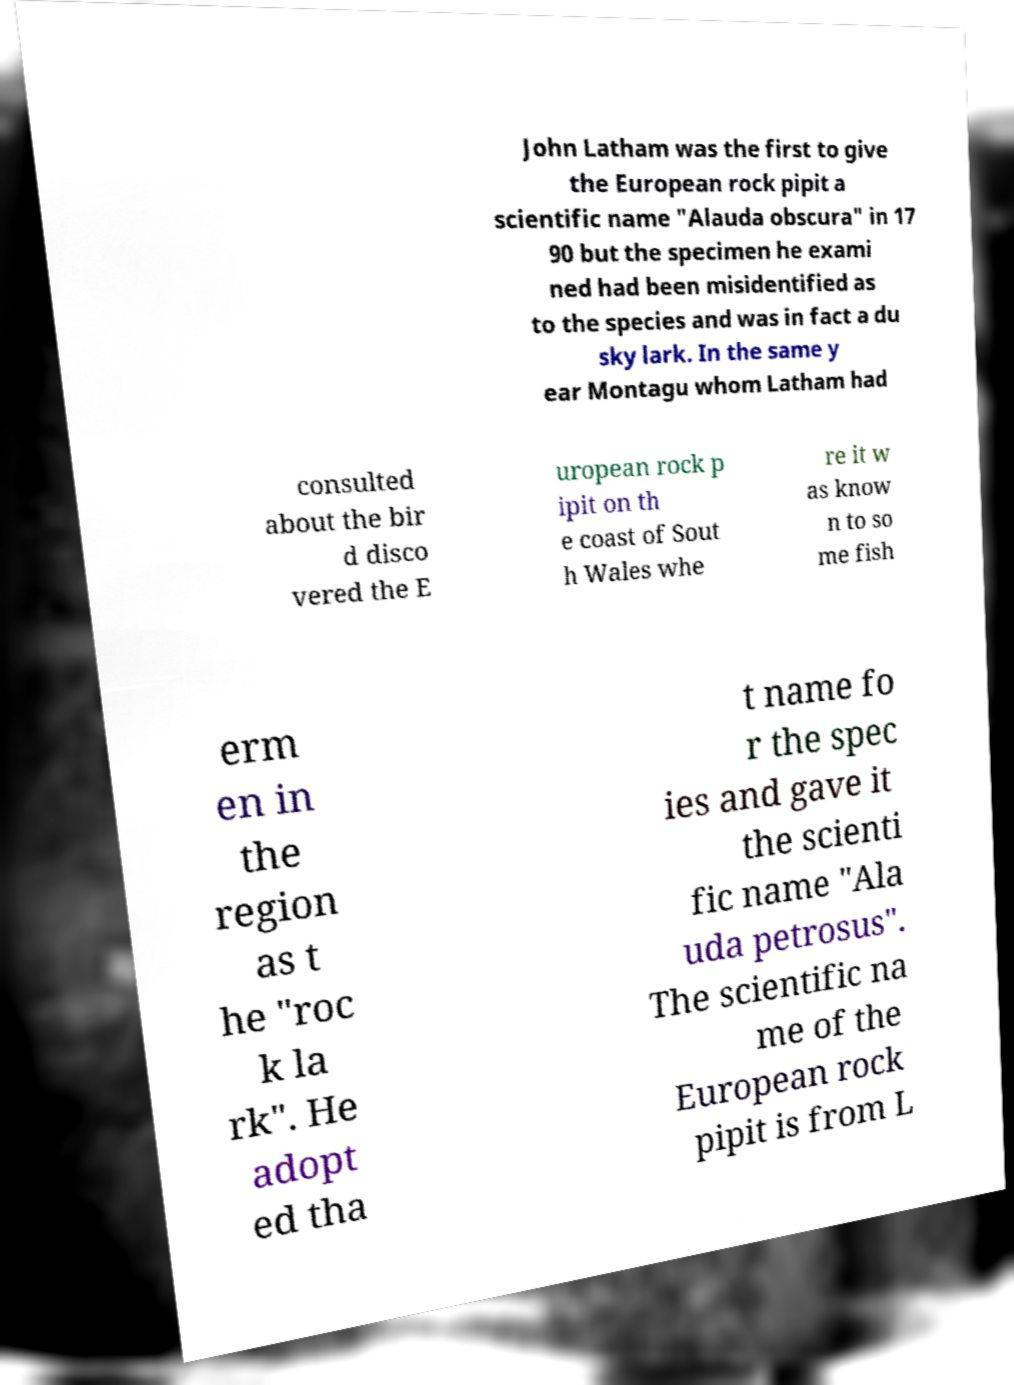Please identify and transcribe the text found in this image. John Latham was the first to give the European rock pipit a scientific name "Alauda obscura" in 17 90 but the specimen he exami ned had been misidentified as to the species and was in fact a du sky lark. In the same y ear Montagu whom Latham had consulted about the bir d disco vered the E uropean rock p ipit on th e coast of Sout h Wales whe re it w as know n to so me fish erm en in the region as t he "roc k la rk". He adopt ed tha t name fo r the spec ies and gave it the scienti fic name "Ala uda petrosus". The scientific na me of the European rock pipit is from L 